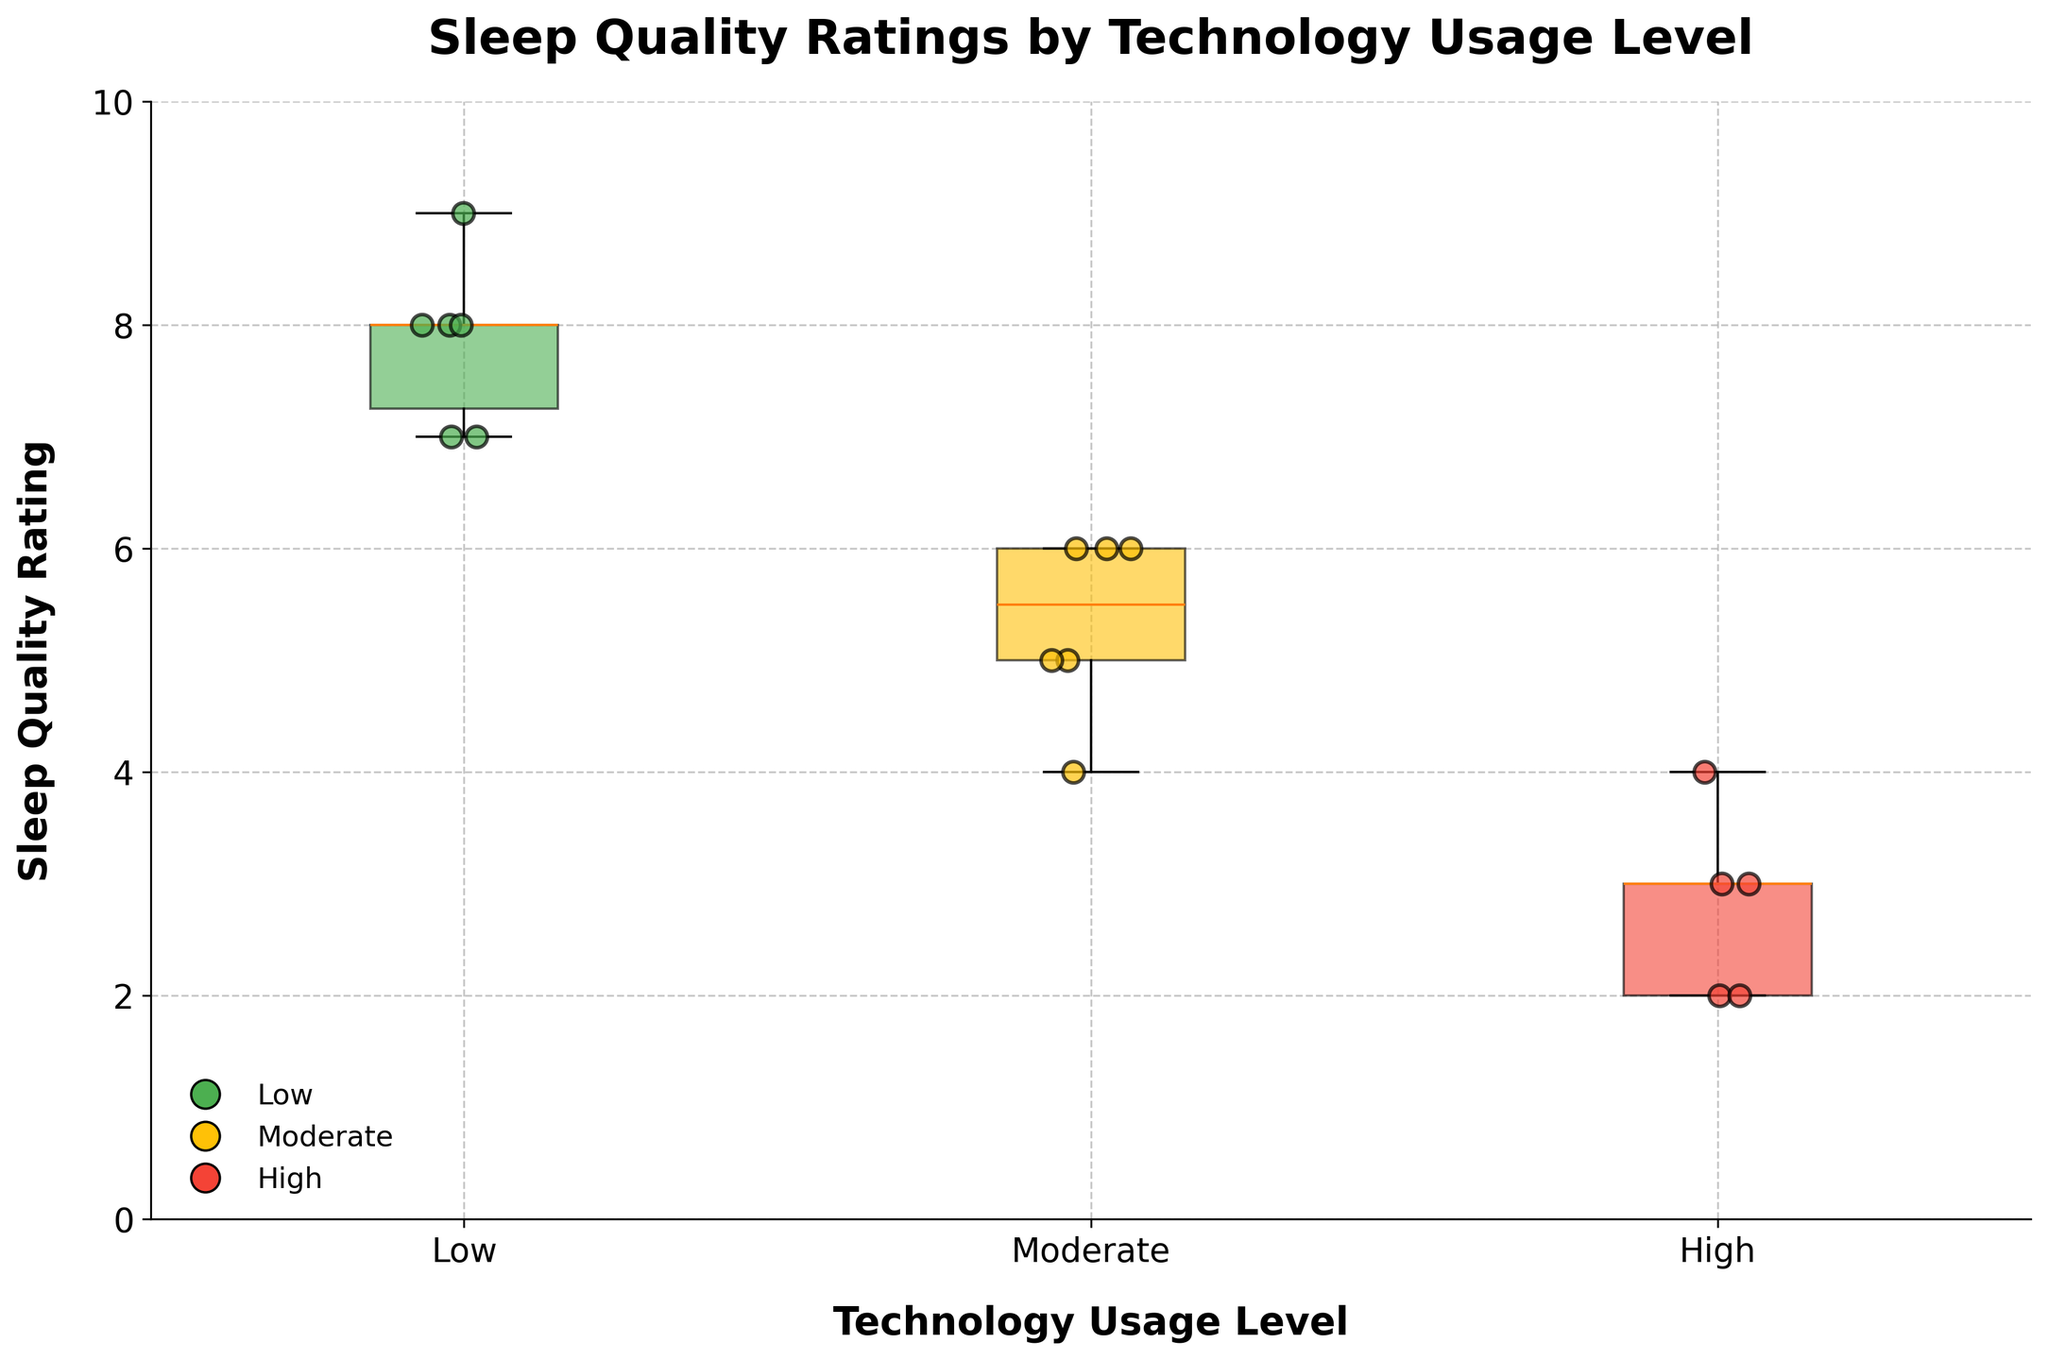How many participants are there in each technology usage level? From the box plot, observe that each technology usage level (Low, Moderate, High) has multiple data points represented as scatter points. By counting the scatter points for each level, we find: Low—5, Moderate—6, High—5.
Answer: Low: 5, Moderate: 6, High: 5 Which technology usage level has the lowest median sleep quality rating? In box plots, the median is shown as the line inside the box. Comparing the medians for each technology usage level visually, the "High" usage level has the lowest median.
Answer: High What is the range of sleep quality ratings for the 'Moderate' technology usage level? In a box plot, the range is determined by the whiskers. For the "Moderate" level, the whiskers extend from the lowest point (4) to the highest point (6).
Answer: 2 Which technology usage level has the most consistent sleep quality ratings? Consistency is indicated by the interquartile range (IQR), the smaller the box, the more consistent. Visually, the "Low" usage level has the smallest IQR, indicating more consistent ratings.
Answer: Low Is there an outlier in the sleep quality ratings for any technology usage level? Outliers are points that lie outside the whiskers. By examining the plot, no scatter points are outside the whiskers for any usage level, hence there are no outliers.
Answer: No Among which technology usage level do the participants with the highest sleep quality ratings fall? The highest sleep quality ratings are indicated by the topmost scatter points. For "Low" usage level, the highest value scatter points are 8 and 9, which are higher than in the other levels.
Answer: Low How many scatter points indicate a sleep quality rating of 5, and which technology usage levels do they belong to? By looking at the scatter points at the rating of 5, we find three points. Observing their positions horizontally with respect to the tech levels, they fall in "Moderate" usage level.
Answer: Moderate: 3 What is the color associated with the 'High' technology usage level, and what does it indicate? Each usage level is represented by a specific color. The "High" usage level is represented by red, which indicates a higher level of technology usage.
Answer: Red Does any technology usage level display sleep quality ratings above 8? By examining the scatter points above the rating of 8, only the "Low" usage level has points at 8 and 9, while the other levels do not exceed 8.
Answer: Low Compare the interquartile ranges (IQR) of sleep quality ratings for 'Low' and 'High' usage levels. Which has a larger IQR? IQR is the difference between the 75th and 25th percentile, shown as the box size. The "High" usage level has a noticeably larger box compared to the "Low" usage level, thus a larger IQR.
Answer: High 